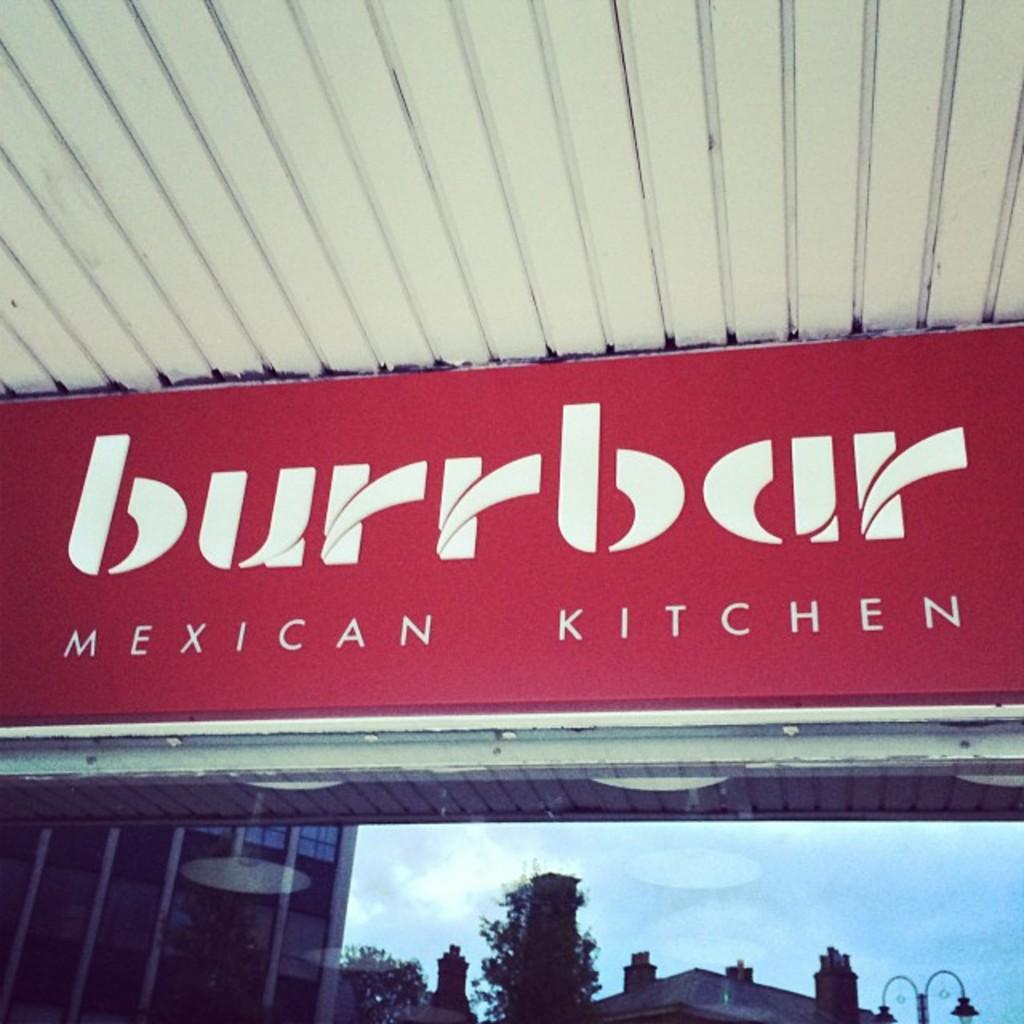<image>
Write a terse but informative summary of the picture. A red sign with white letters reads burrbar Mexican Kitchen. 